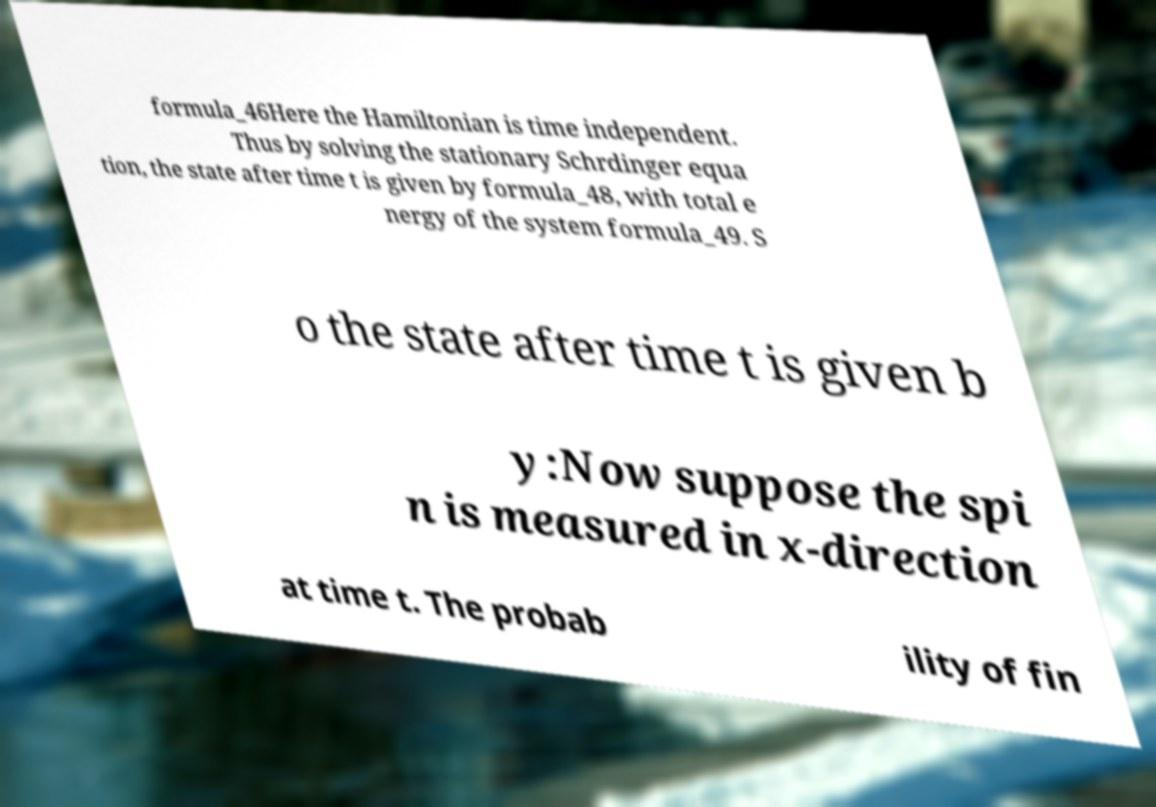Could you assist in decoding the text presented in this image and type it out clearly? formula_46Here the Hamiltonian is time independent. Thus by solving the stationary Schrdinger equa tion, the state after time t is given by formula_48, with total e nergy of the system formula_49. S o the state after time t is given b y:Now suppose the spi n is measured in x-direction at time t. The probab ility of fin 